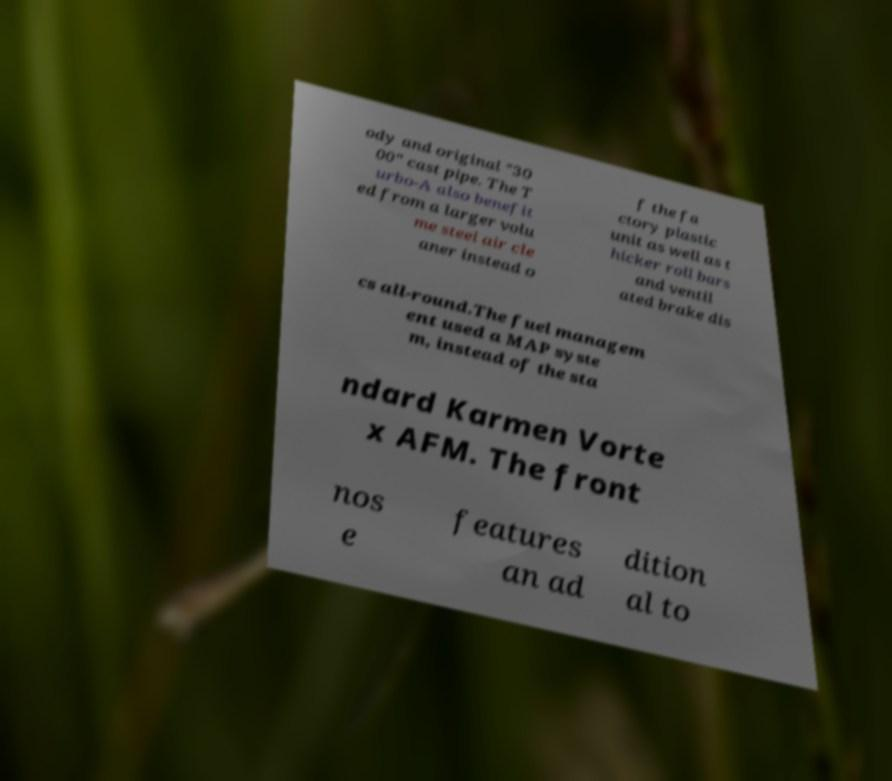Could you extract and type out the text from this image? ody and original "30 00" cast pipe. The T urbo-A also benefit ed from a larger volu me steel air cle aner instead o f the fa ctory plastic unit as well as t hicker roll bars and ventil ated brake dis cs all-round.The fuel managem ent used a MAP syste m, instead of the sta ndard Karmen Vorte x AFM. The front nos e features an ad dition al to 